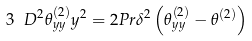<formula> <loc_0><loc_0><loc_500><loc_500>3 \ D { ^ { 2 } \theta _ { y y } ^ { ( 2 ) } } { y ^ { 2 } } = 2 P r \delta ^ { 2 } \left ( \theta _ { y y } ^ { ( 2 ) } - \theta ^ { ( 2 ) } \right )</formula> 